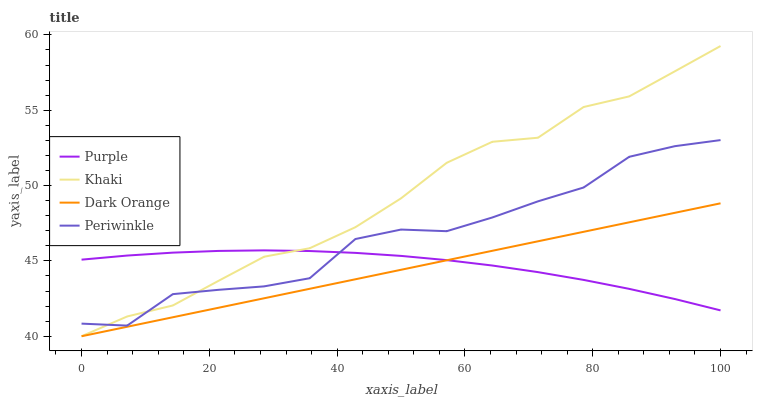Does Dark Orange have the minimum area under the curve?
Answer yes or no. Yes. Does Khaki have the maximum area under the curve?
Answer yes or no. Yes. Does Khaki have the minimum area under the curve?
Answer yes or no. No. Does Dark Orange have the maximum area under the curve?
Answer yes or no. No. Is Dark Orange the smoothest?
Answer yes or no. Yes. Is Periwinkle the roughest?
Answer yes or no. Yes. Is Khaki the smoothest?
Answer yes or no. No. Is Khaki the roughest?
Answer yes or no. No. Does Dark Orange have the lowest value?
Answer yes or no. Yes. Does Periwinkle have the lowest value?
Answer yes or no. No. Does Khaki have the highest value?
Answer yes or no. Yes. Does Dark Orange have the highest value?
Answer yes or no. No. Is Dark Orange less than Periwinkle?
Answer yes or no. Yes. Is Periwinkle greater than Dark Orange?
Answer yes or no. Yes. Does Purple intersect Khaki?
Answer yes or no. Yes. Is Purple less than Khaki?
Answer yes or no. No. Is Purple greater than Khaki?
Answer yes or no. No. Does Dark Orange intersect Periwinkle?
Answer yes or no. No. 